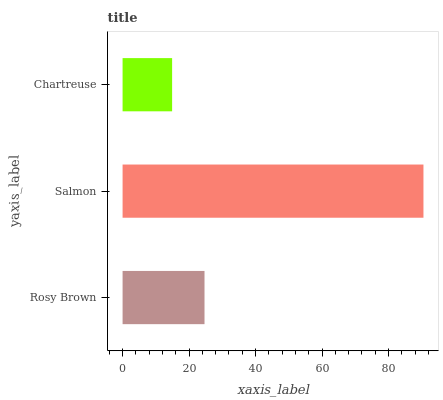Is Chartreuse the minimum?
Answer yes or no. Yes. Is Salmon the maximum?
Answer yes or no. Yes. Is Salmon the minimum?
Answer yes or no. No. Is Chartreuse the maximum?
Answer yes or no. No. Is Salmon greater than Chartreuse?
Answer yes or no. Yes. Is Chartreuse less than Salmon?
Answer yes or no. Yes. Is Chartreuse greater than Salmon?
Answer yes or no. No. Is Salmon less than Chartreuse?
Answer yes or no. No. Is Rosy Brown the high median?
Answer yes or no. Yes. Is Rosy Brown the low median?
Answer yes or no. Yes. Is Salmon the high median?
Answer yes or no. No. Is Chartreuse the low median?
Answer yes or no. No. 